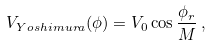Convert formula to latex. <formula><loc_0><loc_0><loc_500><loc_500>V _ { Y o s h i m u r a } ( \phi ) = V _ { 0 } \cos \frac { \phi _ { r } } { M } \, ,</formula> 